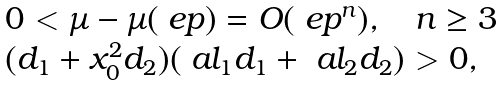Convert formula to latex. <formula><loc_0><loc_0><loc_500><loc_500>\begin{array} { l } 0 < \mu - \mu ( \ e p ) = O ( \ e p ^ { n } ) , \quad n \geq 3 \\ ( d _ { 1 } + x _ { 0 } ^ { 2 } d _ { 2 } ) ( \ a l _ { 1 } d _ { 1 } + \ a l _ { 2 } d _ { 2 } ) > 0 , \end{array}</formula> 